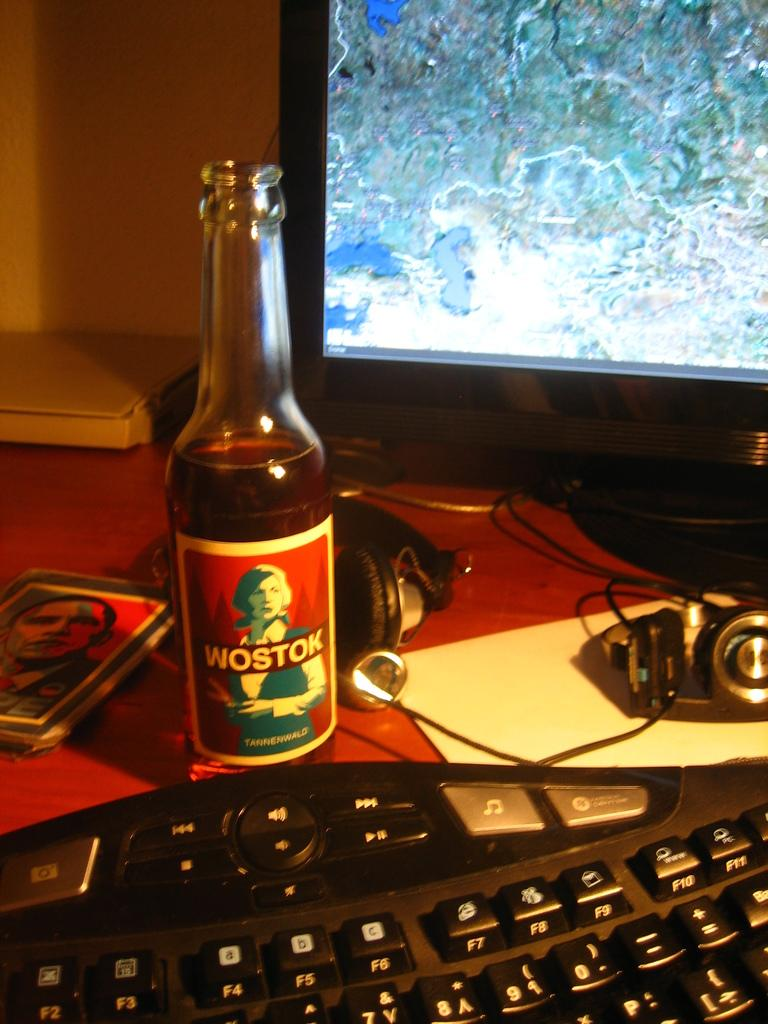What is on the table in the image? There is a wine bottle, a keyboard, and a headset on the table. Are there any other objects on the table? Yes, there are other objects on the table. What is in front of the table? There is a computer in front of the table. What type of alarm is present on the table in the image? There is no alarm present on the table in the image. Can you tell me how the parent is interacting with the objects on the table in the image? There is no parent present in the image, and therefore no interaction with the objects can be observed. 